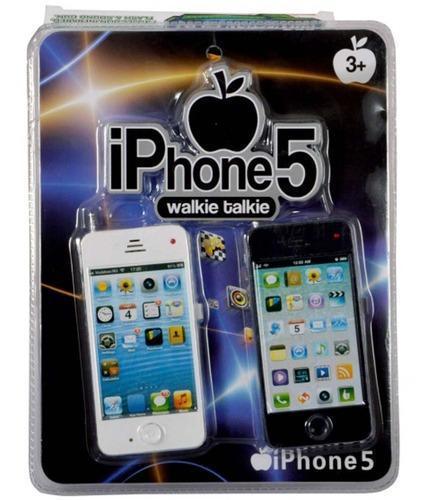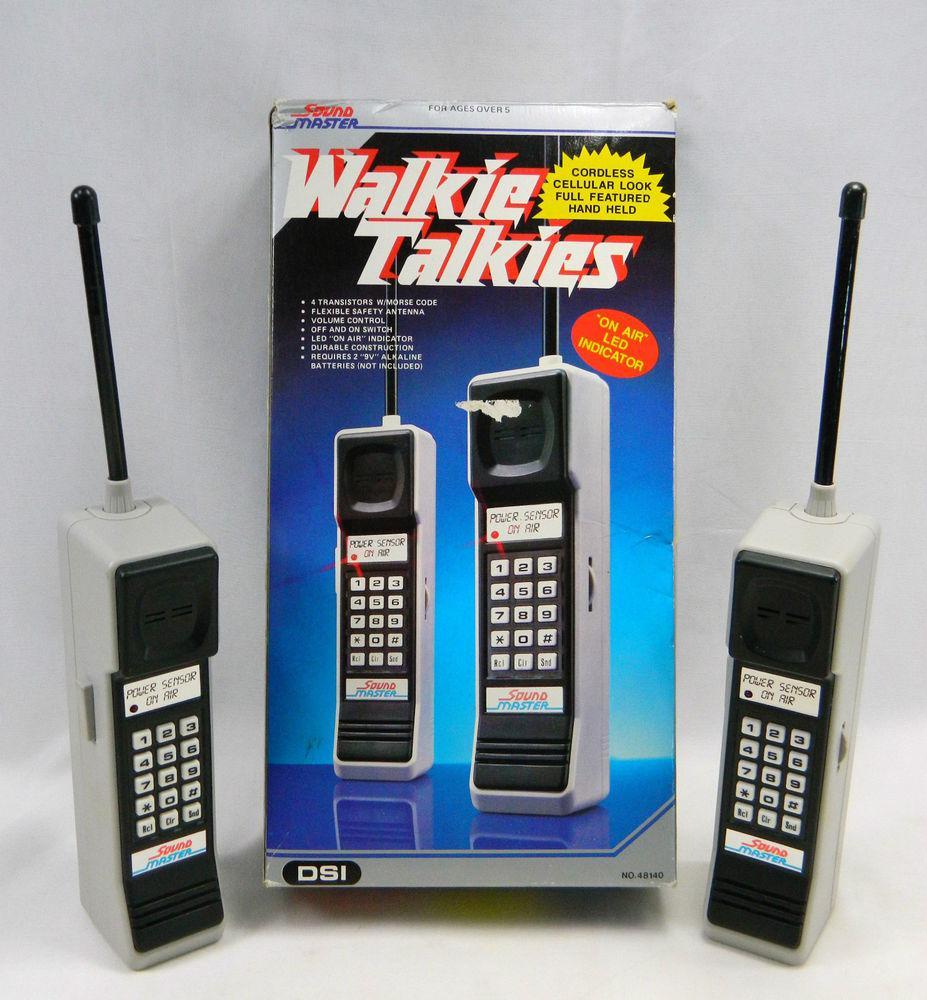The first image is the image on the left, the second image is the image on the right. For the images displayed, is the sentence "Each image includes a horizontal row of various cell phones displayed upright in size order." factually correct? Answer yes or no. No. 